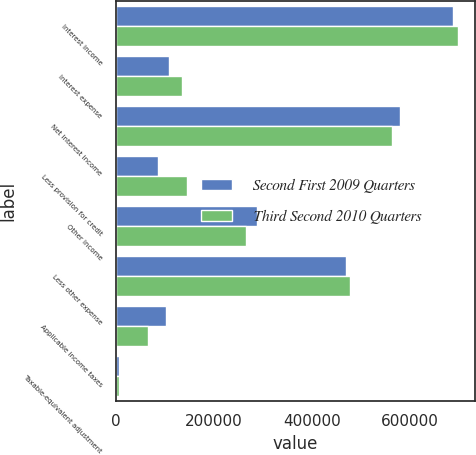Convert chart to OTSL. <chart><loc_0><loc_0><loc_500><loc_500><stacked_bar_chart><ecel><fcel>Interest income<fcel>Interest expense<fcel>Net interest income<fcel>Less provision for credit<fcel>Other income<fcel>Less other expense<fcel>Applicable income taxes<fcel>Taxable-equivalent adjustment<nl><fcel>Second First 2009 Quarters<fcel>688855<fcel>108628<fcel>580227<fcel>85000<fcel>286938<fcel>469274<fcel>102319<fcel>6130<nl><fcel>Third Second 2010 Quarters<fcel>698556<fcel>133950<fcel>564606<fcel>145000<fcel>265890<fcel>478451<fcel>64340<fcel>5887<nl></chart> 